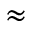Convert formula to latex. <formula><loc_0><loc_0><loc_500><loc_500>\approx</formula> 